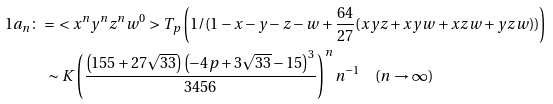Convert formula to latex. <formula><loc_0><loc_0><loc_500><loc_500>1 a _ { n } & \colon = \ < x ^ { n } y ^ { n } z ^ { n } w ^ { 0 } > T _ { p } \left ( 1 / ( 1 - x - y - z - w + \frac { 6 4 } { 2 7 } ( x y z + x y w + x z w + y z w ) ) \right ) \\ & \quad \sim K \left ( \frac { \left ( 1 5 5 + 2 7 \sqrt { 3 3 } \right ) \left ( - 4 p + 3 \sqrt { 3 3 } - 1 5 \right ) ^ { 3 } } { 3 4 5 6 } \right ) ^ { n } n ^ { - 1 } \quad ( n \to \infty )</formula> 